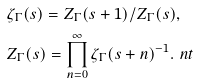<formula> <loc_0><loc_0><loc_500><loc_500>& \zeta _ { \Gamma } ( s ) = Z _ { \Gamma } ( s + 1 ) / Z _ { \Gamma } ( s ) , \\ & Z _ { \Gamma } ( s ) = \prod _ { n = 0 } ^ { \infty } \zeta _ { \Gamma } ( s + n ) ^ { - 1 } . \ n t</formula> 